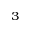<formula> <loc_0><loc_0><loc_500><loc_500>_ { 3 }</formula> 